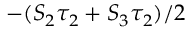<formula> <loc_0><loc_0><loc_500><loc_500>- ( S _ { 2 } \tau _ { 2 } + S _ { 3 } \tau _ { 2 } ) / 2</formula> 